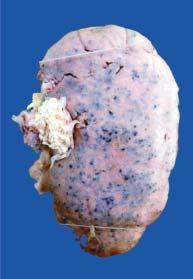s the kidney enlarged in size and weight?
Answer the question using a single word or phrase. Yes 